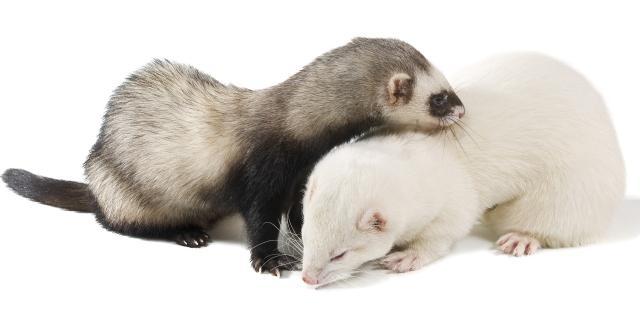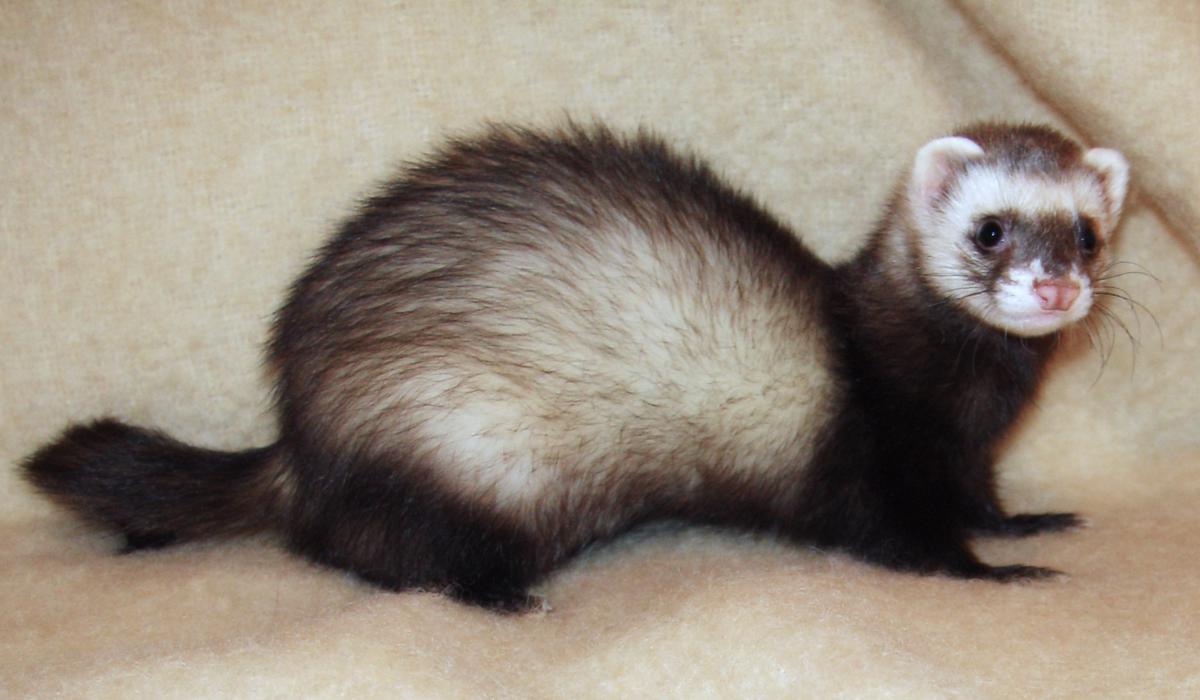The first image is the image on the left, the second image is the image on the right. Considering the images on both sides, is "The left image contains more ferrets than the right image." valid? Answer yes or no. Yes. 